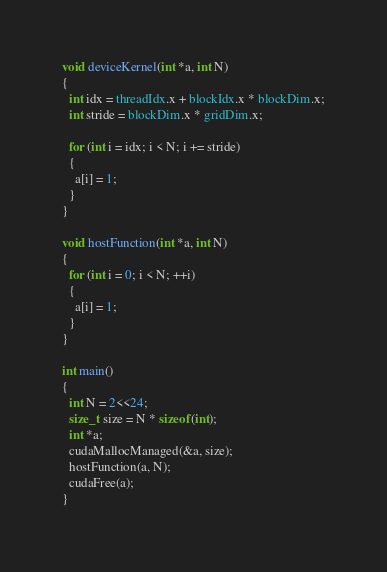Convert code to text. <code><loc_0><loc_0><loc_500><loc_500><_Cuda_>void deviceKernel(int *a, int N)
{
  int idx = threadIdx.x + blockIdx.x * blockDim.x;
  int stride = blockDim.x * gridDim.x;

  for (int i = idx; i < N; i += stride)
  {
    a[i] = 1;
  }
}

void hostFunction(int *a, int N)
{
  for (int i = 0; i < N; ++i)
  {
    a[i] = 1;
  }
}

int main()
{
  int N = 2<<24;
  size_t size = N * sizeof(int);
  int *a;
  cudaMallocManaged(&a, size);
  hostFunction(a, N);
  cudaFree(a);
}
</code> 